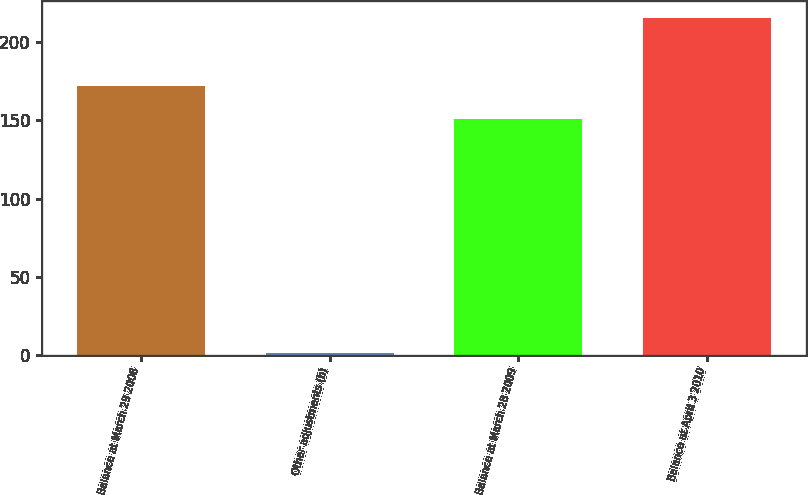<chart> <loc_0><loc_0><loc_500><loc_500><bar_chart><fcel>Balance at March 29 2008<fcel>Other adjustments (b)<fcel>Balance at March 28 2009<fcel>Balance at April 3 2010<nl><fcel>172.25<fcel>1.3<fcel>150.8<fcel>215.8<nl></chart> 